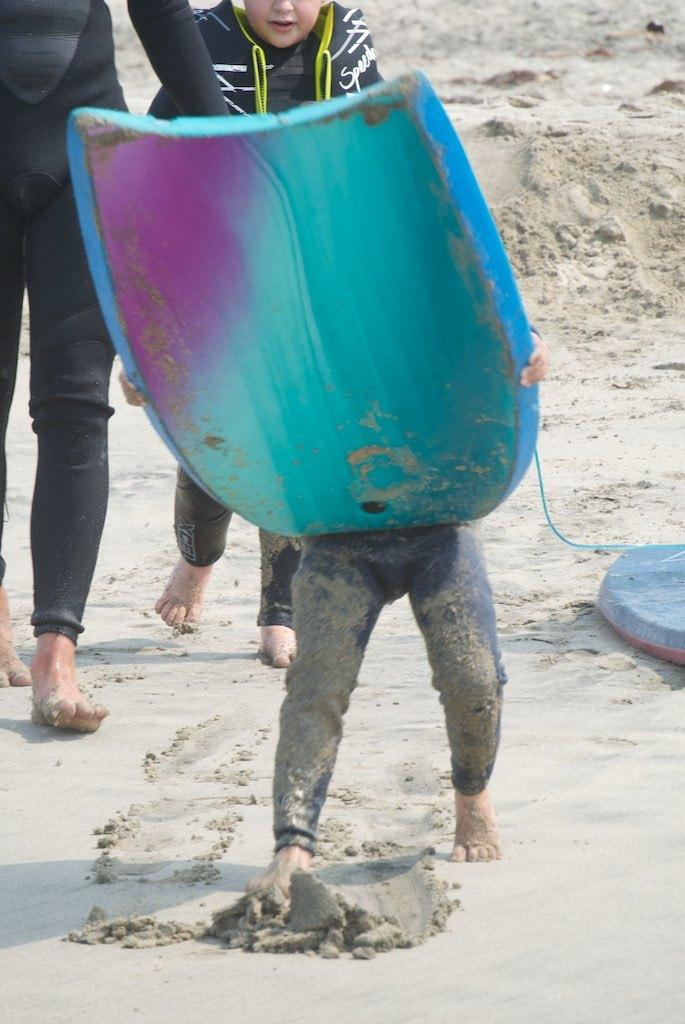What are the people in the image doing? The people in the image are walking on the ground. Can you describe what the person holding an object is doing? The person is holding an object in their hands. What type of star can be seen in the sky in the image? There is no sky visible in the image, so it is not possible to determine if a star is present. What direction is the hen facing in the image? There is no hen present in the image. 